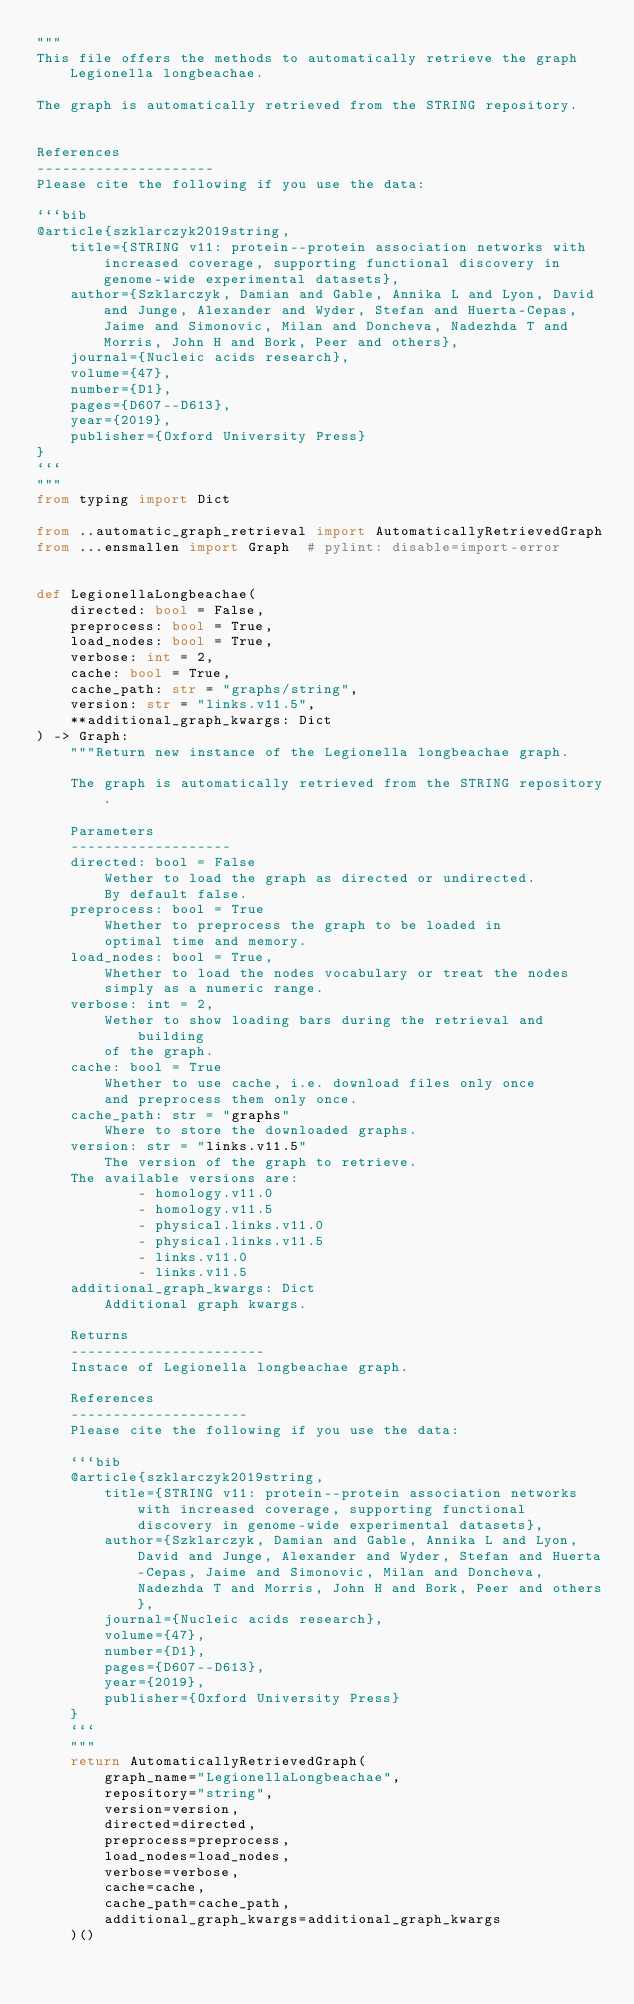<code> <loc_0><loc_0><loc_500><loc_500><_Python_>"""
This file offers the methods to automatically retrieve the graph Legionella longbeachae.

The graph is automatically retrieved from the STRING repository. 


References
---------------------
Please cite the following if you use the data:

```bib
@article{szklarczyk2019string,
    title={STRING v11: protein--protein association networks with increased coverage, supporting functional discovery in genome-wide experimental datasets},
    author={Szklarczyk, Damian and Gable, Annika L and Lyon, David and Junge, Alexander and Wyder, Stefan and Huerta-Cepas, Jaime and Simonovic, Milan and Doncheva, Nadezhda T and Morris, John H and Bork, Peer and others},
    journal={Nucleic acids research},
    volume={47},
    number={D1},
    pages={D607--D613},
    year={2019},
    publisher={Oxford University Press}
}
```
"""
from typing import Dict

from ..automatic_graph_retrieval import AutomaticallyRetrievedGraph
from ...ensmallen import Graph  # pylint: disable=import-error


def LegionellaLongbeachae(
    directed: bool = False,
    preprocess: bool = True,
    load_nodes: bool = True,
    verbose: int = 2,
    cache: bool = True,
    cache_path: str = "graphs/string",
    version: str = "links.v11.5",
    **additional_graph_kwargs: Dict
) -> Graph:
    """Return new instance of the Legionella longbeachae graph.

    The graph is automatically retrieved from the STRING repository.	

    Parameters
    -------------------
    directed: bool = False
        Wether to load the graph as directed or undirected.
        By default false.
    preprocess: bool = True
        Whether to preprocess the graph to be loaded in 
        optimal time and memory.
    load_nodes: bool = True,
        Whether to load the nodes vocabulary or treat the nodes
        simply as a numeric range.
    verbose: int = 2,
        Wether to show loading bars during the retrieval and building
        of the graph.
    cache: bool = True
        Whether to use cache, i.e. download files only once
        and preprocess them only once.
    cache_path: str = "graphs"
        Where to store the downloaded graphs.
    version: str = "links.v11.5"
        The version of the graph to retrieve.		
	The available versions are:
			- homology.v11.0
			- homology.v11.5
			- physical.links.v11.0
			- physical.links.v11.5
			- links.v11.0
			- links.v11.5
    additional_graph_kwargs: Dict
        Additional graph kwargs.

    Returns
    -----------------------
    Instace of Legionella longbeachae graph.

	References
	---------------------
	Please cite the following if you use the data:
	
	```bib
	@article{szklarczyk2019string,
	    title={STRING v11: protein--protein association networks with increased coverage, supporting functional discovery in genome-wide experimental datasets},
	    author={Szklarczyk, Damian and Gable, Annika L and Lyon, David and Junge, Alexander and Wyder, Stefan and Huerta-Cepas, Jaime and Simonovic, Milan and Doncheva, Nadezhda T and Morris, John H and Bork, Peer and others},
	    journal={Nucleic acids research},
	    volume={47},
	    number={D1},
	    pages={D607--D613},
	    year={2019},
	    publisher={Oxford University Press}
	}
	```
    """
    return AutomaticallyRetrievedGraph(
        graph_name="LegionellaLongbeachae",
        repository="string",
        version=version,
        directed=directed,
        preprocess=preprocess,
        load_nodes=load_nodes,
        verbose=verbose,
        cache=cache,
        cache_path=cache_path,
        additional_graph_kwargs=additional_graph_kwargs
    )()
</code> 